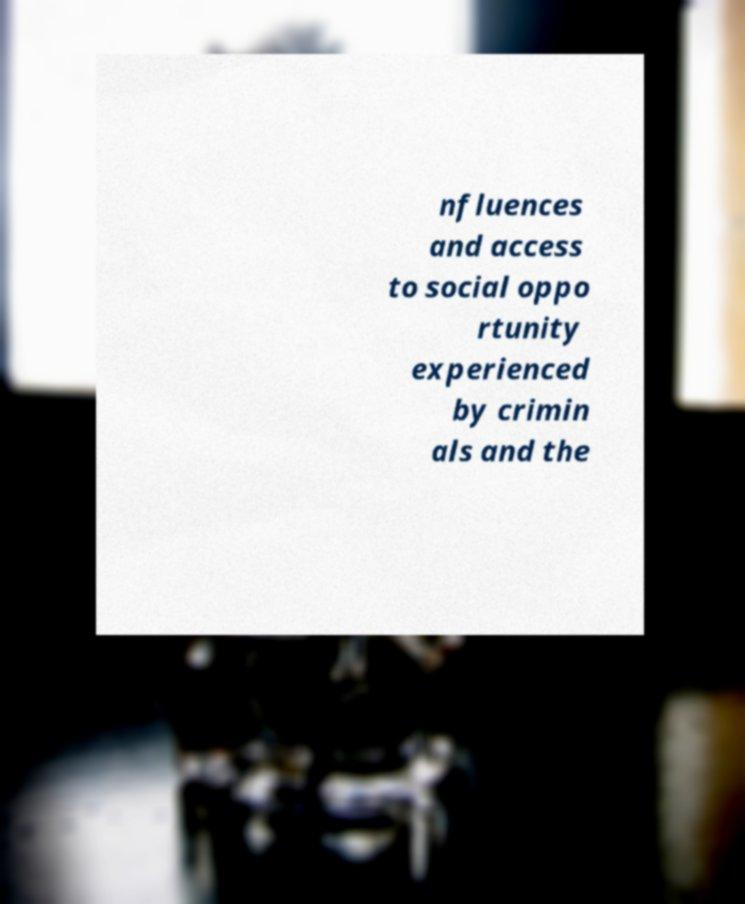What messages or text are displayed in this image? I need them in a readable, typed format. nfluences and access to social oppo rtunity experienced by crimin als and the 